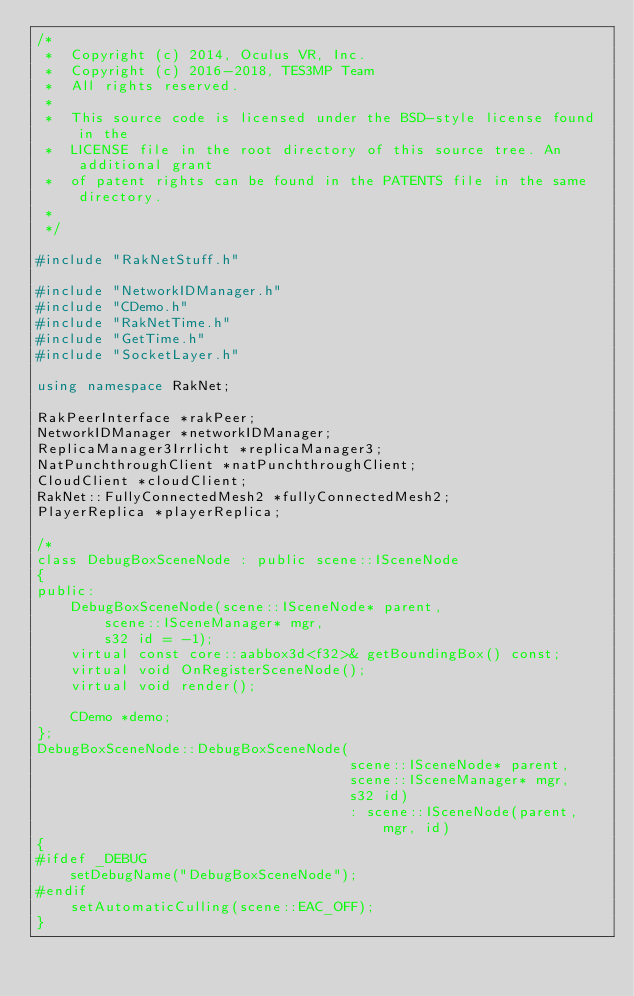Convert code to text. <code><loc_0><loc_0><loc_500><loc_500><_C++_>/*
 *  Copyright (c) 2014, Oculus VR, Inc.
 *  Copyright (c) 2016-2018, TES3MP Team
 *  All rights reserved.
 *
 *  This source code is licensed under the BSD-style license found in the
 *  LICENSE file in the root directory of this source tree. An additional grant 
 *  of patent rights can be found in the PATENTS file in the same directory.
 *
 */

#include "RakNetStuff.h"

#include "NetworkIDManager.h"
#include "CDemo.h"
#include "RakNetTime.h"
#include "GetTime.h"
#include "SocketLayer.h"

using namespace RakNet;

RakPeerInterface *rakPeer;
NetworkIDManager *networkIDManager;
ReplicaManager3Irrlicht *replicaManager3;
NatPunchthroughClient *natPunchthroughClient;
CloudClient *cloudClient;
RakNet::FullyConnectedMesh2 *fullyConnectedMesh2;
PlayerReplica *playerReplica;

/*
class DebugBoxSceneNode : public scene::ISceneNode 
{
public:
	DebugBoxSceneNode(scene::ISceneNode* parent,
		scene::ISceneManager* mgr,
		s32 id = -1);
	virtual const core::aabbox3d<f32>& getBoundingBox() const;
	virtual void OnRegisterSceneNode();
	virtual void render();

	CDemo *demo;
};
DebugBoxSceneNode::DebugBoxSceneNode(
									 scene::ISceneNode* parent,
									 scene::ISceneManager* mgr,
									 s32 id)
									 : scene::ISceneNode(parent, mgr, id)
{
#ifdef _DEBUG
	setDebugName("DebugBoxSceneNode");
#endif
	setAutomaticCulling(scene::EAC_OFF);
} </code> 